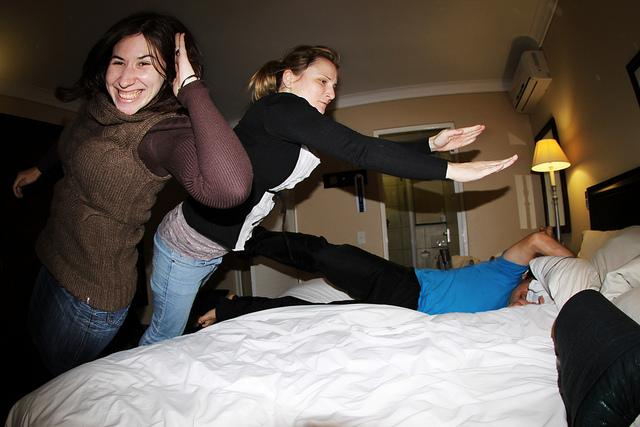It is time to hit the? hay 